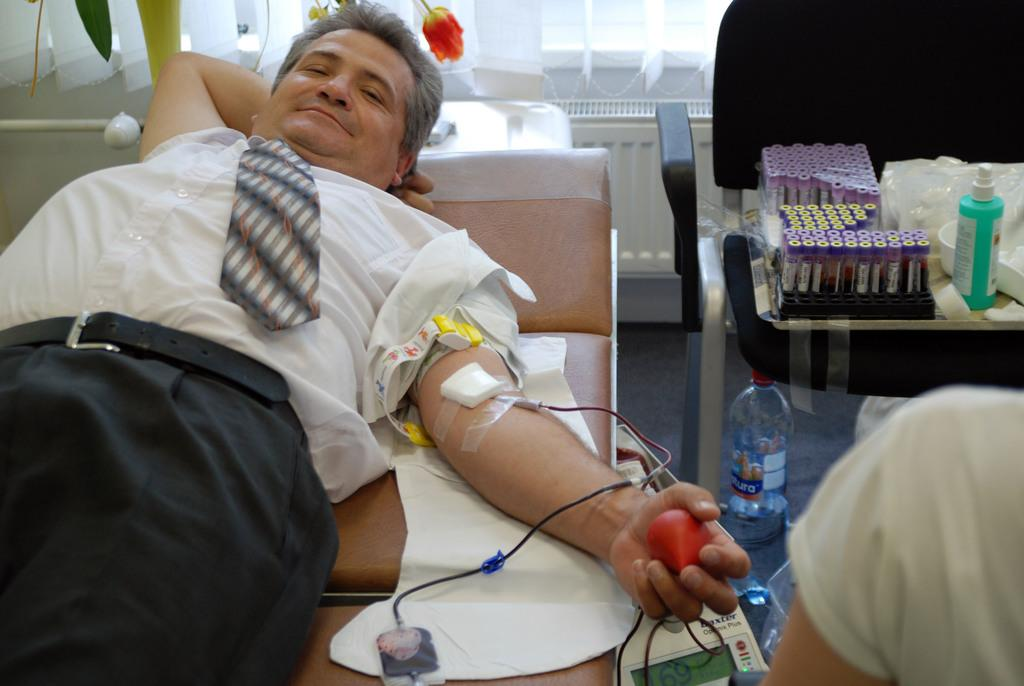What is the man in the image doing? The man is lying on a bed in the image. What is the man holding in his hand? The man is holding an object in his hand. Can you identify any other objects in the image? Yes, there is a water bottle in the image. Are there any other items in the image besides the water bottle? Yes, there are other objects in a box in the image. What type of quiver is the man using to store his sticks in the image? There is no quiver or sticks present in the image. What color is the cap the man is wearing in the image? The man is not wearing a cap in the image. 